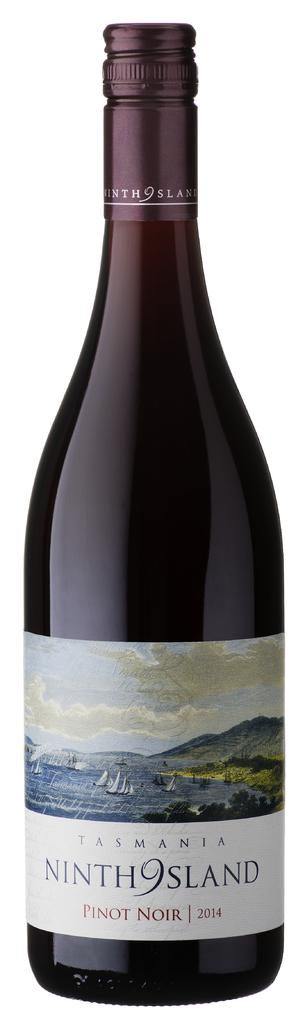<image>
Write a terse but informative summary of the picture. The 2014 Ninth Island Pinot Noir is made by Tasmadia. 